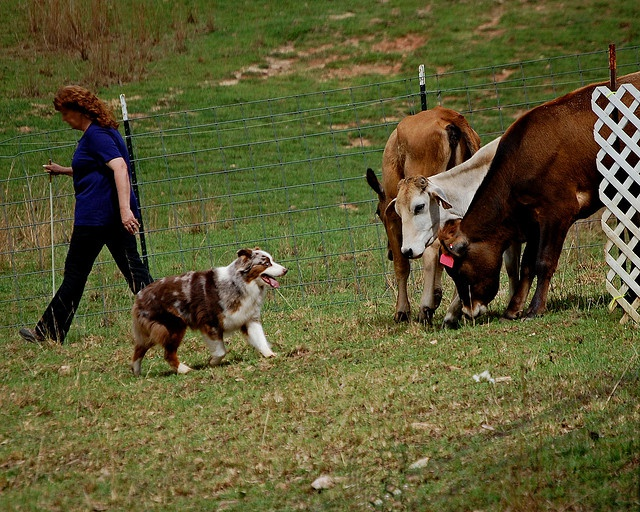Describe the objects in this image and their specific colors. I can see cow in darkgreen, black, maroon, and gray tones, people in darkgreen, black, navy, maroon, and olive tones, dog in darkgreen, black, maroon, olive, and gray tones, cow in darkgreen, black, maroon, and gray tones, and cow in darkgreen, darkgray, tan, and black tones in this image. 